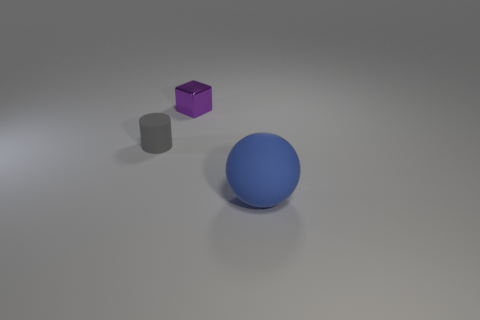Are there any other things that are the same size as the blue rubber sphere?
Make the answer very short. No. Is there anything else that is made of the same material as the small block?
Offer a terse response. No. What number of other objects are there of the same size as the gray matte cylinder?
Provide a short and direct response. 1. What number of objects are either tiny gray matte things in front of the purple cube or objects that are behind the big blue rubber ball?
Ensure brevity in your answer.  2. How many other big rubber objects have the same shape as the blue object?
Offer a very short reply. 0. The thing that is both in front of the purple object and to the right of the cylinder is made of what material?
Keep it short and to the point. Rubber. There is a cylinder; what number of tiny cubes are behind it?
Provide a short and direct response. 1. What number of brown objects are there?
Ensure brevity in your answer.  0. Does the cylinder have the same size as the blue sphere?
Provide a succinct answer. No. Are there any small purple shiny things that are behind the matte object on the right side of the matte thing to the left of the large thing?
Provide a succinct answer. Yes. 